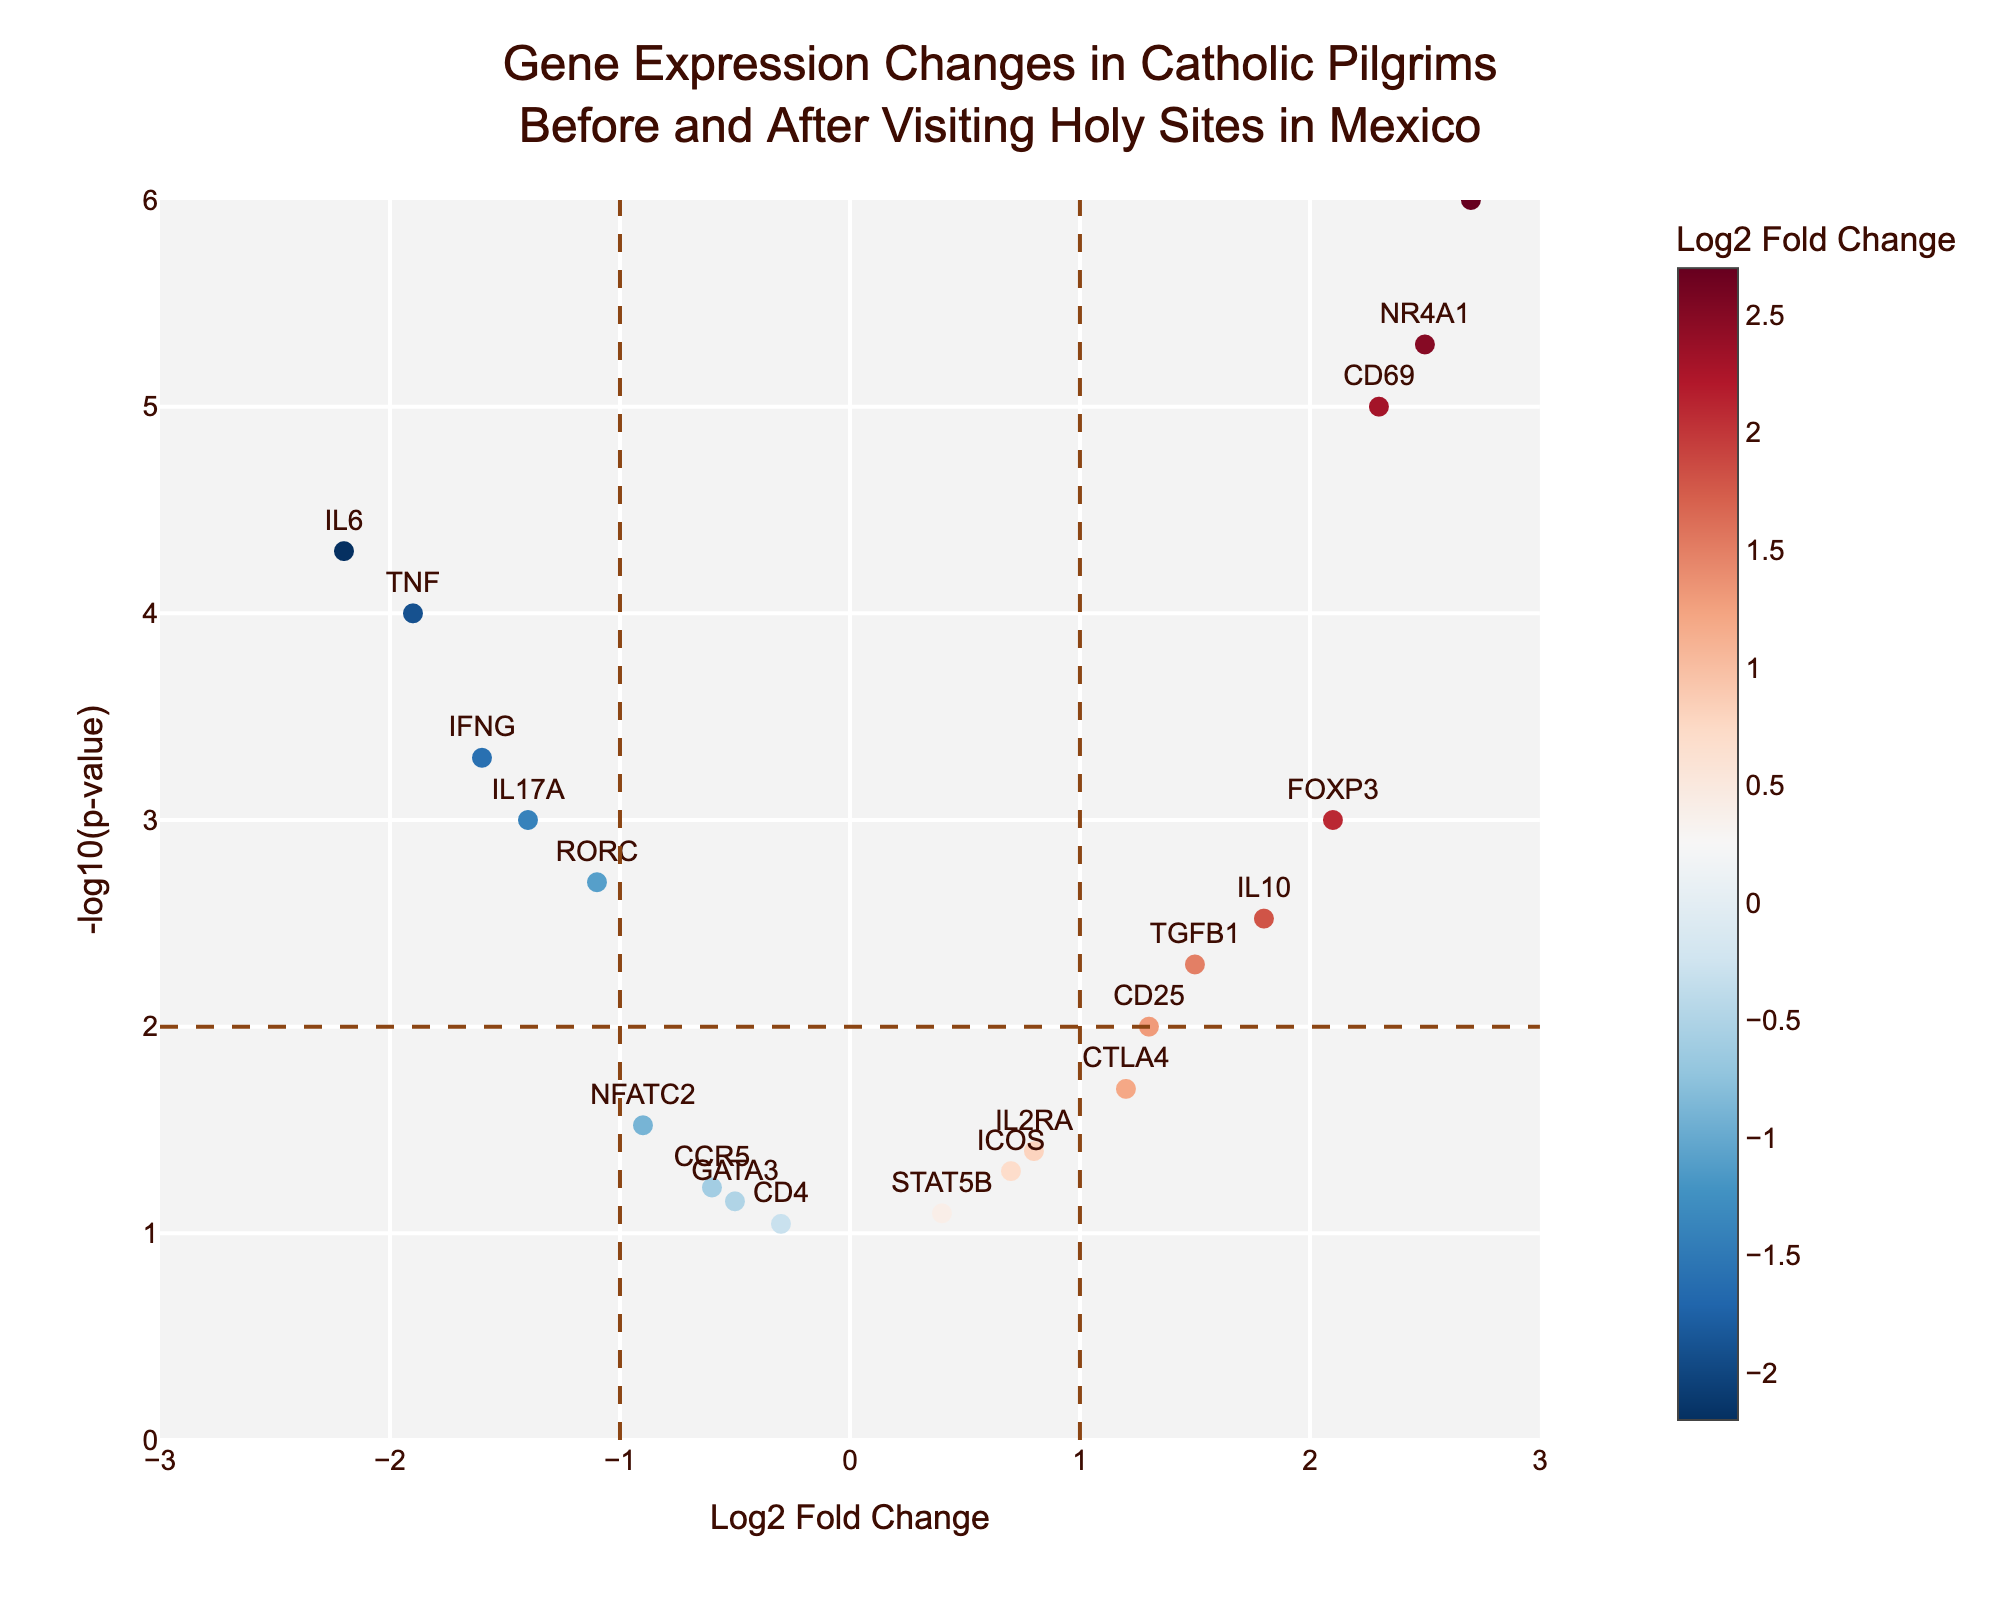What is the title of the figure? The title of the figure is displayed at the top, highlighting what the graph represents. The text indicates the objective of the study.
Answer: Gene Expression Changes in Catholic Pilgrims Before and After Visiting Holy Sites in Mexico What are the labels of the axes in the plot? The labels of the axes indicate the parameters compared in the plot. The x-axis represents "Log2 Fold Change," while the y-axis shows "-log10(p-value)."
Answer: Log2 Fold Change and -log10(p-value) How many genes have a Log2 Fold Change greater than 1? By examining the plot and noting the number of points to the right of the vertical line x=1, we identify the genes with a Log2 Fold Change greater than 1. The genes are CD69, NR4A1, EGR1, and FOXP3. Four data points are clearly on the right side of the threshold.
Answer: 4 Which genes are significantly upregulated (Log2 Fold Change > 1 and p-value < 0.01)? Genes that are upregulated and significant must fall to the right of the x=1 vertical line and above the y=2 horizontal line. These genes are CD69, NR4A1, and EGR1.
Answer: CD69, NR4A1, EGR1 Which gene has the most substantial downregulation? The gene with the most substantial downregulation will have the lowest value in the Log2 Fold Change axis (most negative value). IFNG is the most downregulated gene with a Log2 Fold Change of -1.6.
Answer: IFNG Among the genes with p-values less than 0.01, which has the lowest Log2 Fold Change? The genes with p-values less than 0.01 are checked for the lowest Log2 Fold Change. IL6, IFNG, and TNF fall below the threshold, with IL6 having the lowest Log2 Fold Change of -2.2.
Answer: IL6 What is the Log2 Fold Change of IL10, and where does it fall in the figure? By pinpointing IL10's position and reading its values, we identify that it is on the right of the origin at x=1.8. Its Log2 Fold Change is clearly displayed when highlighted.
Answer: 1.8 Which genes are near the significance threshold line (p-value = 0.01)? By locating the horizontal line at y=2, we can identify the data points near it. Genes CD25 and CTLA4 are close to the threshold line but on different sides.
Answer: CD25, CTLA4 How many genes have a p-value < 0.01? The significant genes are those above the y=2 horizontal line. These genes are identified based on their position relative to the threshold. Counting these genes gives us 9 significant ones.
Answer: 9 